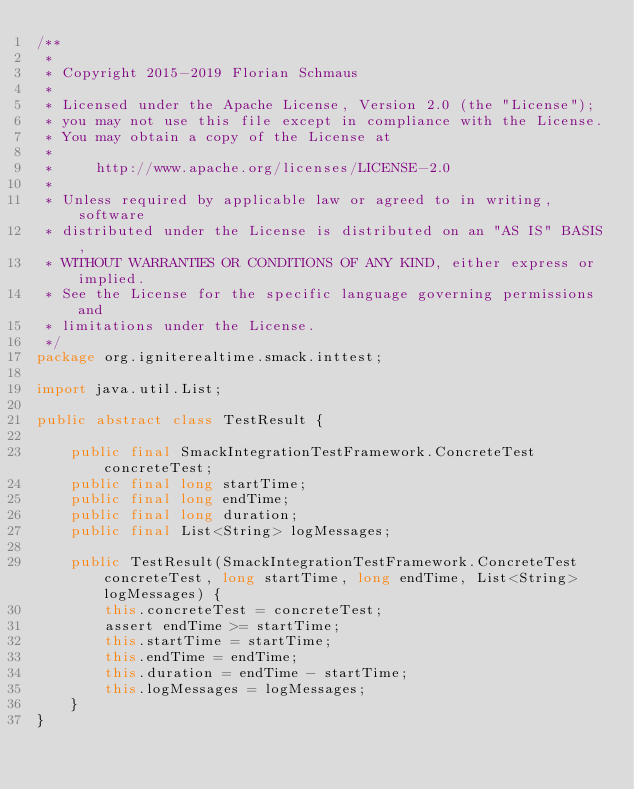Convert code to text. <code><loc_0><loc_0><loc_500><loc_500><_Java_>/**
 *
 * Copyright 2015-2019 Florian Schmaus
 *
 * Licensed under the Apache License, Version 2.0 (the "License");
 * you may not use this file except in compliance with the License.
 * You may obtain a copy of the License at
 *
 *     http://www.apache.org/licenses/LICENSE-2.0
 *
 * Unless required by applicable law or agreed to in writing, software
 * distributed under the License is distributed on an "AS IS" BASIS,
 * WITHOUT WARRANTIES OR CONDITIONS OF ANY KIND, either express or implied.
 * See the License for the specific language governing permissions and
 * limitations under the License.
 */
package org.igniterealtime.smack.inttest;

import java.util.List;

public abstract class TestResult {

    public final SmackIntegrationTestFramework.ConcreteTest concreteTest;
    public final long startTime;
    public final long endTime;
    public final long duration;
    public final List<String> logMessages;

    public TestResult(SmackIntegrationTestFramework.ConcreteTest concreteTest, long startTime, long endTime, List<String> logMessages) {
        this.concreteTest = concreteTest;
        assert endTime >= startTime;
        this.startTime = startTime;
        this.endTime = endTime;
        this.duration = endTime - startTime;
        this.logMessages = logMessages;
    }
}
</code> 